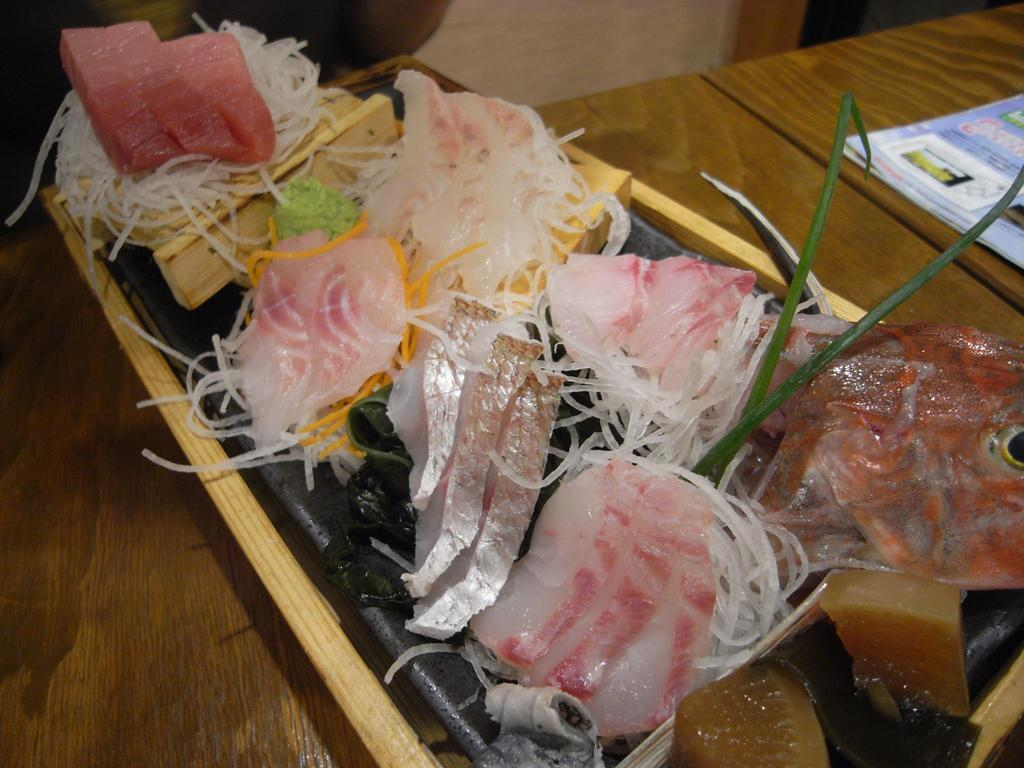What type of dishware is being used to hold the food items in the image? There are food items on a black plate in the image. Where is the plate located? The plate is on a tray in the image. What surface is the tray resting on? The tray is on a wooden table in the image. Are there any other objects on the table? Yes, there is a book on the table in the image. How many passengers are visible in the image? There are no passengers present in the image. What rule is being enforced by the hand in the image? There is no hand or rule present in the image. 